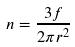Convert formula to latex. <formula><loc_0><loc_0><loc_500><loc_500>n = \frac { 3 f } { 2 \pi r ^ { 2 } }</formula> 